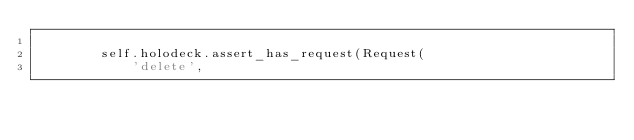<code> <loc_0><loc_0><loc_500><loc_500><_Python_>
        self.holodeck.assert_has_request(Request(
            'delete',</code> 